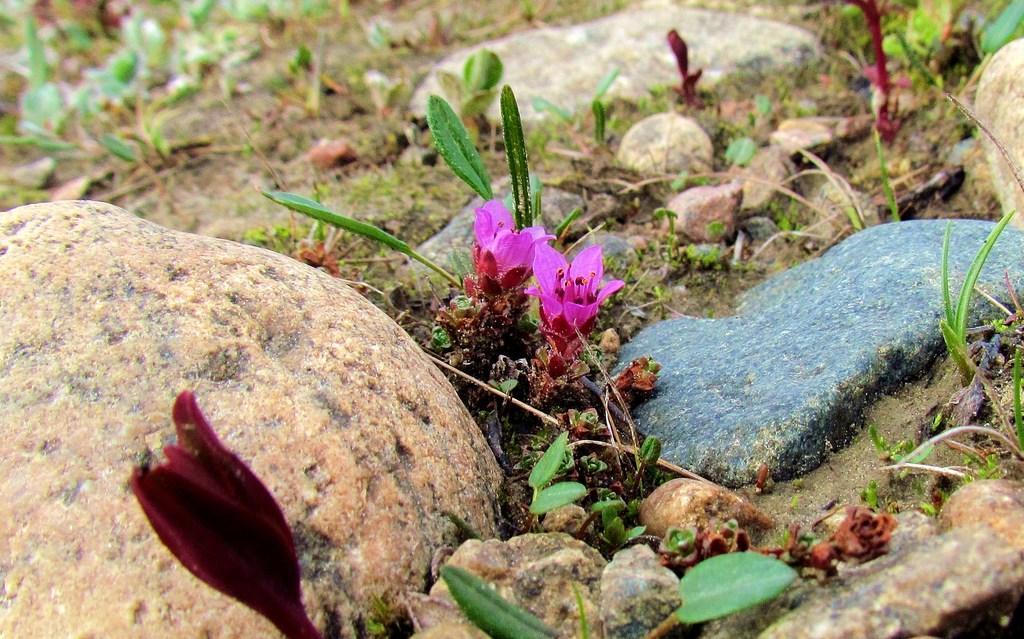How would you summarize this image in a sentence or two? This image consists of flowers in pink and red color. At the bottom, there are small plants on the ground. And we can see many rocks along with green grass on the ground. 